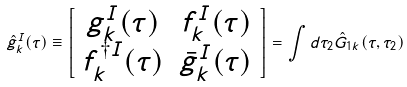Convert formula to latex. <formula><loc_0><loc_0><loc_500><loc_500>\hat { g } ^ { I } _ { k } ( \tau ) \equiv \left [ \begin{array} { c c } g ^ { I } _ { k } ( \tau ) & f ^ { I } _ { k } ( \tau ) \\ f ^ { \dagger I } _ { k } ( \tau ) & \bar { g } ^ { I } _ { k } ( \tau ) \end{array} \right ] = \int d \tau _ { 2 } \hat { G } _ { 1 k } ( \tau , \tau _ { 2 } )</formula> 